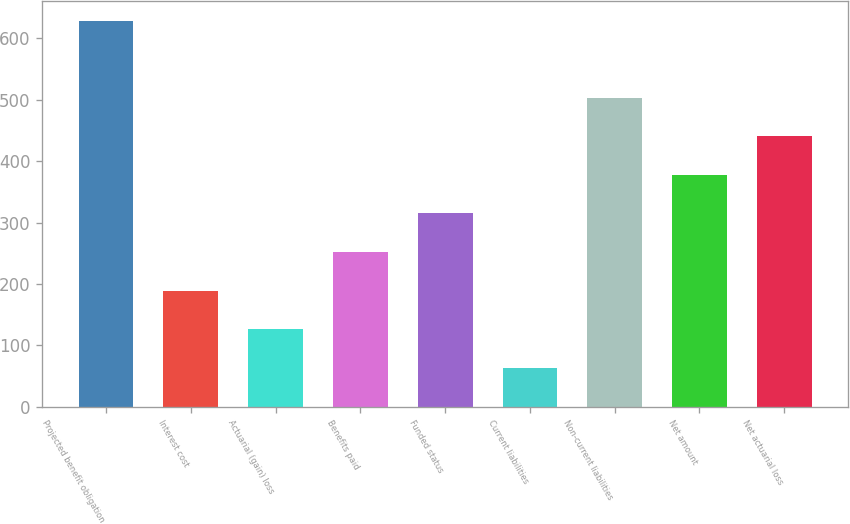Convert chart. <chart><loc_0><loc_0><loc_500><loc_500><bar_chart><fcel>Projected benefit obligation<fcel>Interest cost<fcel>Actuarial (gain) loss<fcel>Benefits paid<fcel>Funded status<fcel>Current liabilities<fcel>Non-current liabilities<fcel>Net amount<fcel>Net actuarial loss<nl><fcel>628.8<fcel>189.2<fcel>126.4<fcel>252<fcel>314.8<fcel>63.6<fcel>503.2<fcel>377.6<fcel>440.4<nl></chart> 